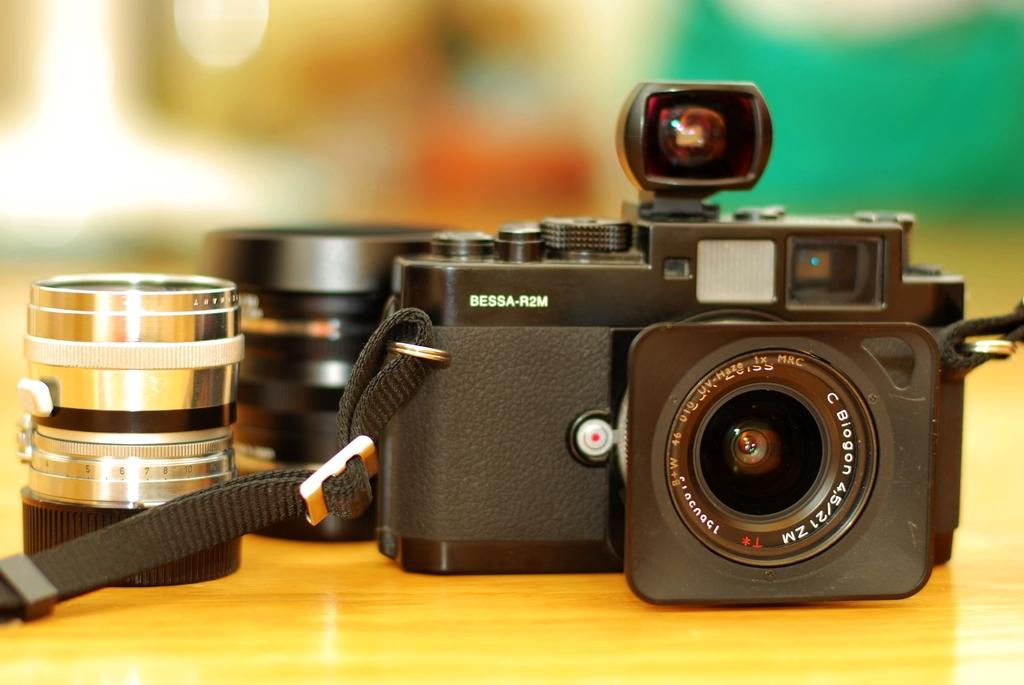What object is the main subject of the image? There is a black camera in the image. What part of the camera is specifically mentioned in the image? The camera has a lens. Where is the camera and lens placed in the image? The camera and lens are placed on a table. How would you describe the background of the image? The background of the image is blurred. How many ants are crawling on the camera lens in the image? There are no ants present in the image; it only features a black camera with a lens. What direction is the camera pointing in the image? The facts provided do not mention the direction the camera is pointing, so we cannot determine that information from the image. 